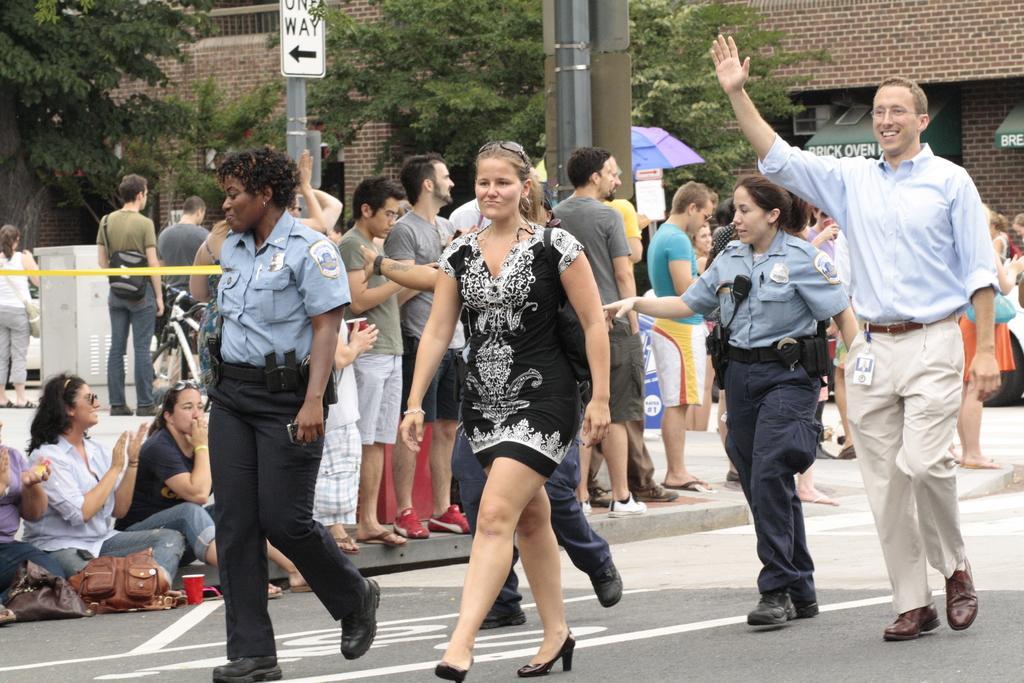Describe this image in one or two sentences. In this image we can see persons standing on the road and some persons sitting on the footpath. In the background we can see sign boards, poles, umbrella, trees and buildings. 